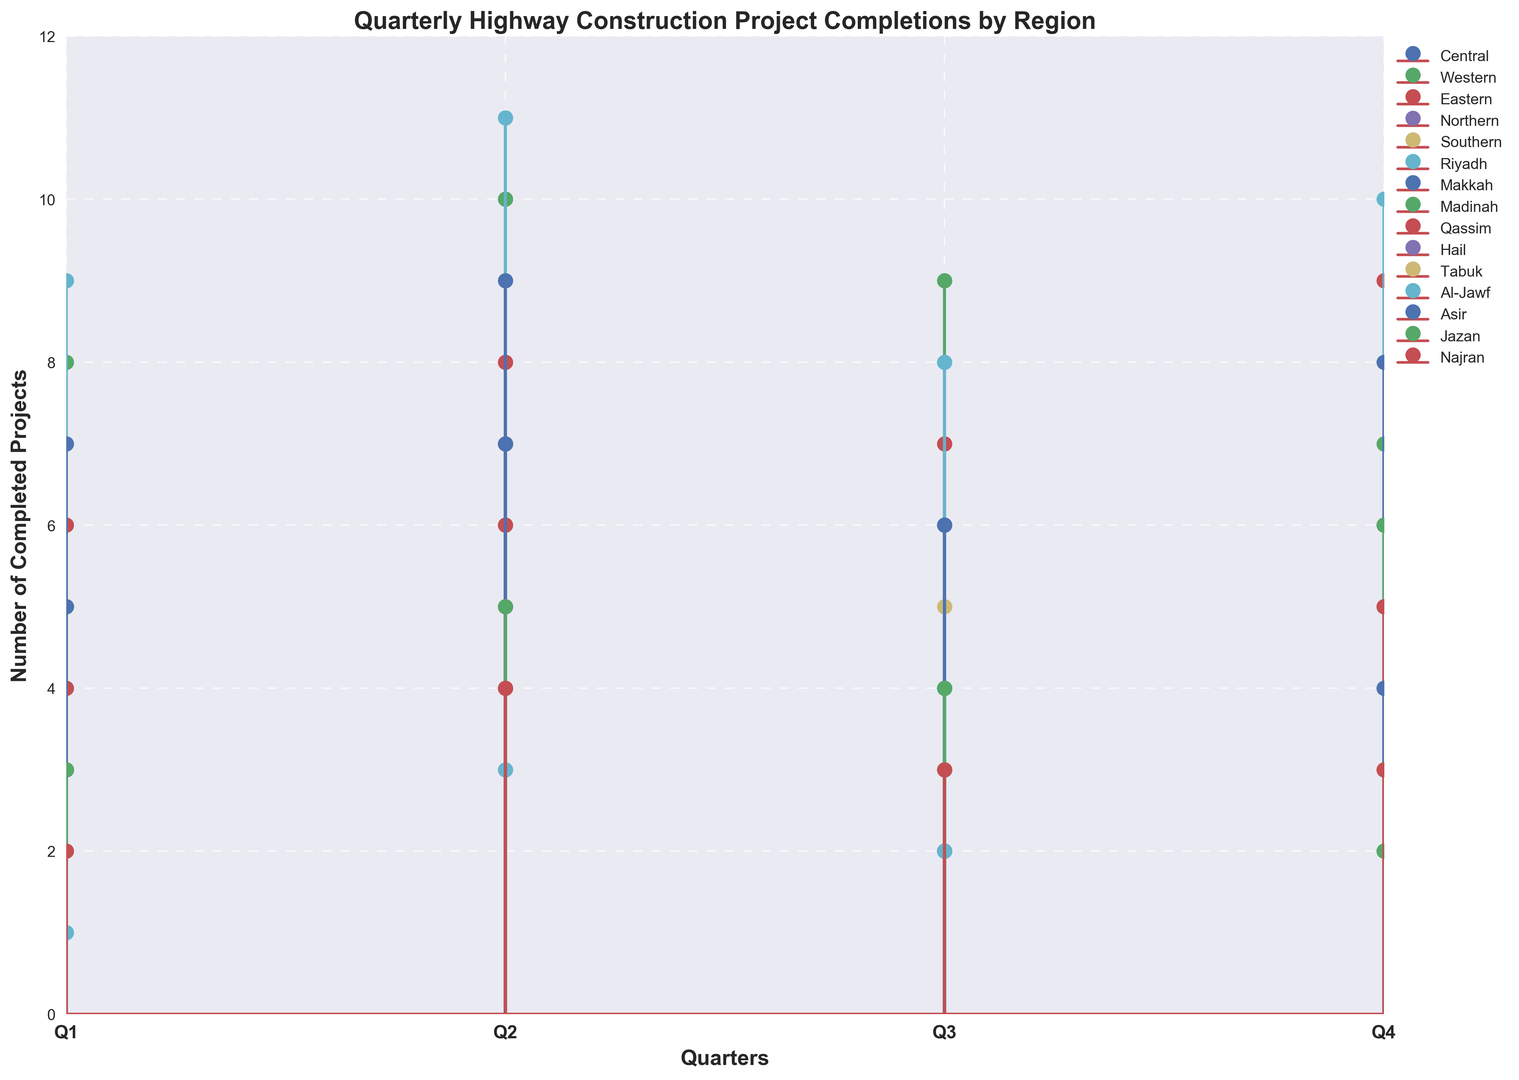Which region completed the most highway construction projects in Q2? To find the region that completed the most projects, look at the heights of the stem lines in Q2. The Riyadh region has the tallest stem, indicating the highest number of completions.
Answer: Riyadh In which quarter did the Northern region complete the least number of projects? Review the stem lengths for the Northern region across all quarters. The smallest stem appears in Q3, indicating the least number of completions.
Answer: Q3 What is the total number of projects completed by the Western region in the year? Sum the values for the Western region across all quarters: 8 (Q1) + 10 (Q2) + 9 (Q3) + 7 (Q4).
Answer: 34 Compare project completions between Q3 in the Central and Q1 in the Southern region. Which is higher? Evaluate the heights of the stems: The Central region in Q3 has a value of 4, while the Southern region in Q1 has a value of 4. Therefore, they are equal.
Answer: Equal How does the number of completed projects in Madinah in Q3 compare to those in Makkah in Q3? Compare the stem heights for both regions in Q3. Madinah completed 4 projects, while Makkah completed 6. Therefore, Makkah has more completions.
Answer: Makkah Which region has the most consistent performance throughout the quarters? Consistency can be evaluated by checking the variability of the stem heights for each region. Western and Eastern regions have relatively even stem heights over the quarters, but the Eastern region shows the least variability.
Answer: Eastern What is the average number of projects completed by the Hail region per quarter? Calculate the sum of Hail's quarterly completions and divide by the number of quarters: (3 + 5 + 2 + 4) / 4.
Answer: 3.5 Who had a higher total project completion for Q4, Al-Jawf or Najran? Compare the values for Al-Jawf and Najran in Q4. Al-Jawf completed 2 projects, while Najran completed 3. Najran has more completions.
Answer: Najran Which quarter has the highest overall project completions across all regions? Sum the total number of completions for each quarter: Q1 (67), Q2 (90), Q3 (64), Q4 (77). Q2 has the highest total completions.
Answer: Q2 